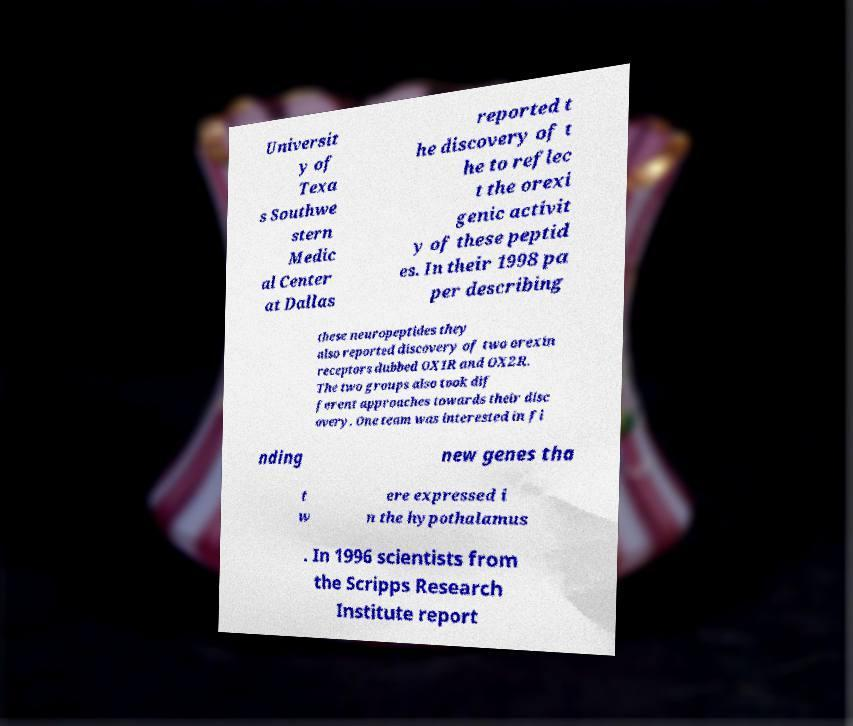Could you assist in decoding the text presented in this image and type it out clearly? Universit y of Texa s Southwe stern Medic al Center at Dallas reported t he discovery of t he to reflec t the orexi genic activit y of these peptid es. In their 1998 pa per describing these neuropeptides they also reported discovery of two orexin receptors dubbed OX1R and OX2R. The two groups also took dif ferent approaches towards their disc overy. One team was interested in fi nding new genes tha t w ere expressed i n the hypothalamus . In 1996 scientists from the Scripps Research Institute report 